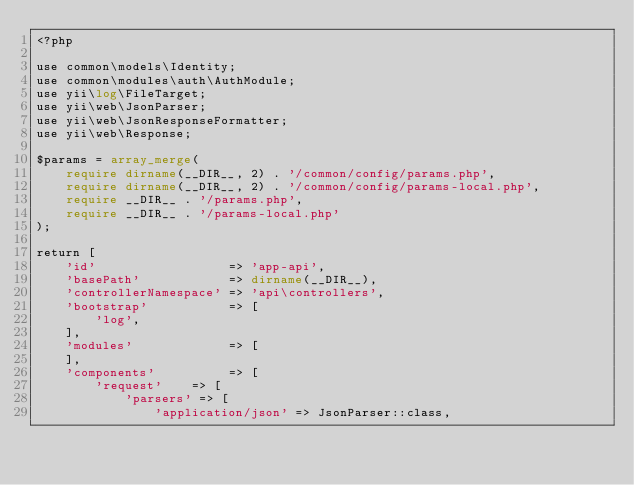Convert code to text. <code><loc_0><loc_0><loc_500><loc_500><_PHP_><?php

use common\models\Identity;
use common\modules\auth\AuthModule;
use yii\log\FileTarget;
use yii\web\JsonParser;
use yii\web\JsonResponseFormatter;
use yii\web\Response;

$params = array_merge(
    require dirname(__DIR__, 2) . '/common/config/params.php',
    require dirname(__DIR__, 2) . '/common/config/params-local.php',
    require __DIR__ . '/params.php',
    require __DIR__ . '/params-local.php'
);

return [
    'id'                  => 'app-api',
    'basePath'            => dirname(__DIR__),
    'controllerNamespace' => 'api\controllers',
    'bootstrap'           => [
        'log',
    ],
    'modules'             => [
    ],
    'components'          => [
        'request'    => [
            'parsers' => [
                'application/json' => JsonParser::class,</code> 